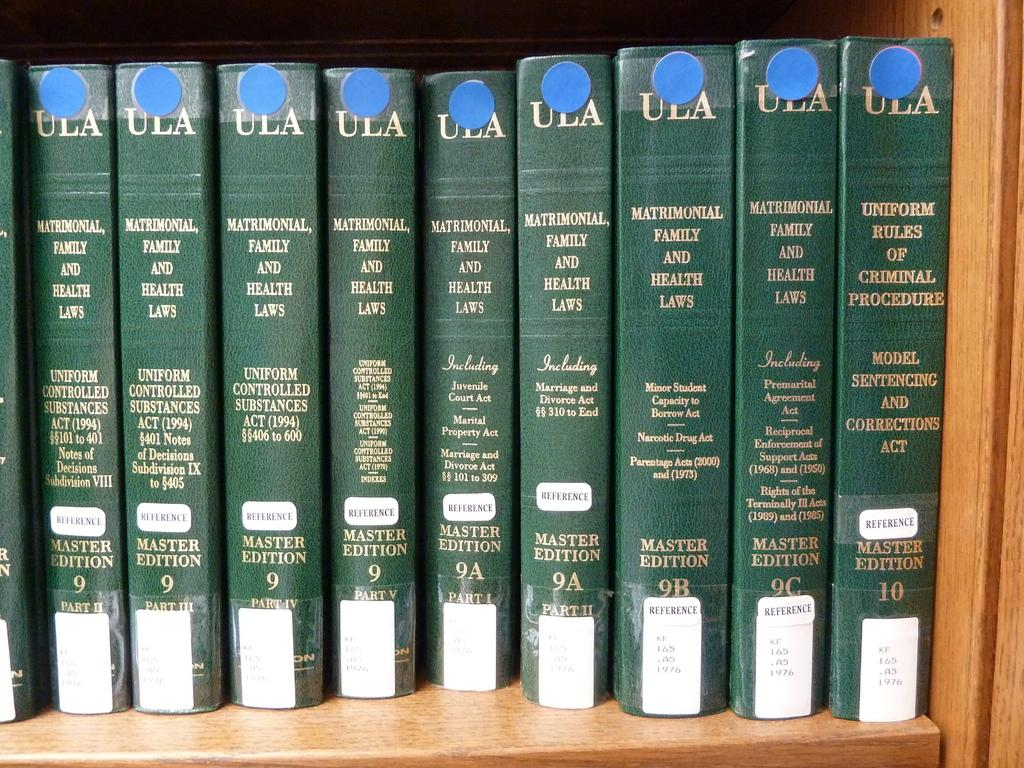Provide a one-sentence caption for the provided image. A group of books with the wording mathmatical family and health laws. 